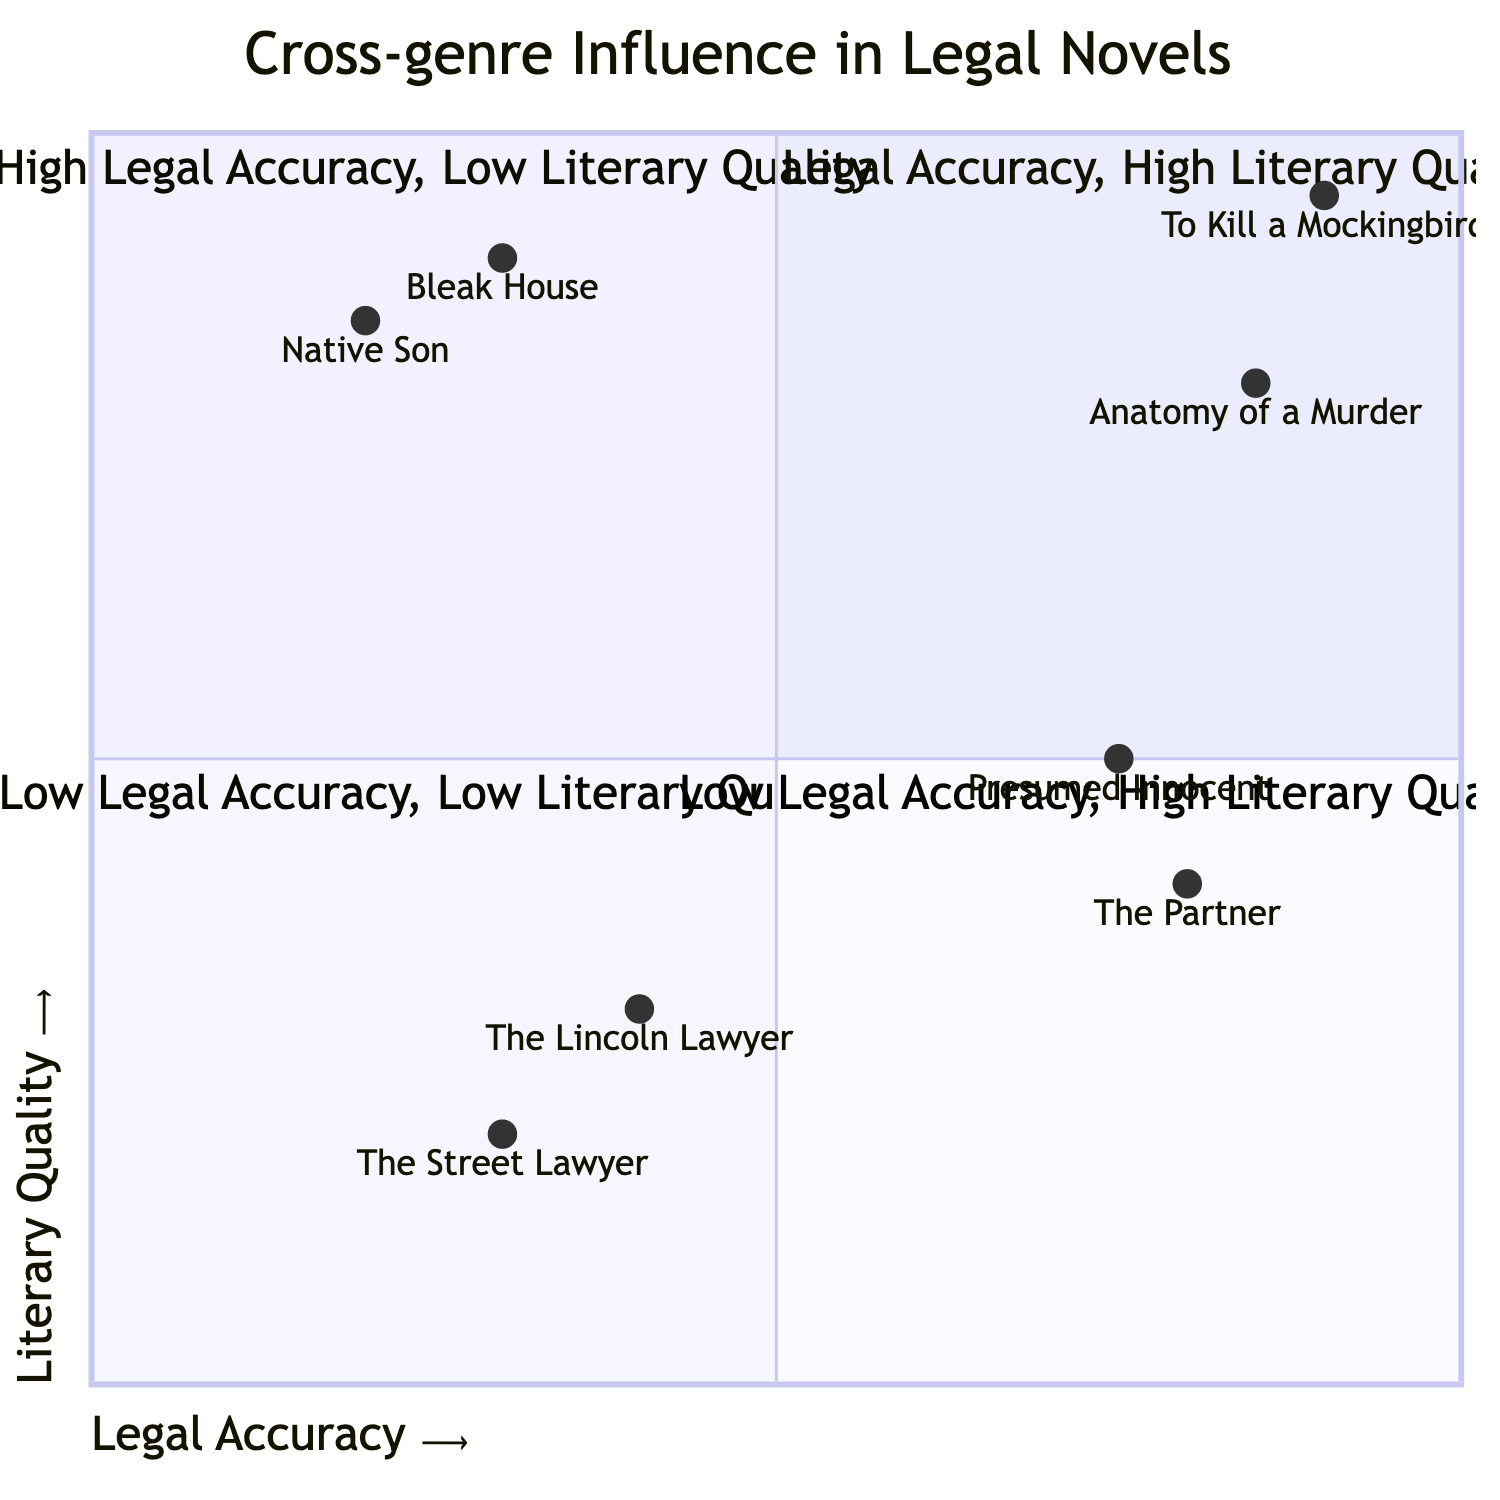What is the title of the novel in the High Legal Accuracy, High Literary Quality quadrant? The High Legal Accuracy, High Literary Quality quadrant includes notable examples; from the provided data, "To Kill a Mockingbird" by Harper Lee is listed as one of the novels in this quadrant.
Answer: To Kill a Mockingbird How many novels are in the Low Legal Accuracy, Low Literary Quality quadrant? The Low Legal Accuracy, Low Literary Quality quadrant contains two examples: "The Lincoln Lawyer" and "The Street Lawyer". Therefore, the total number of novels in this quadrant is two.
Answer: 2 Which novel has the highest literary quality among the ones in the diagram? By examining the values in the quadrants, "To Kill a Mockingbird" has the highest literary quality at 0.95, making it the novel with the highest literary quality overall.
Answer: To Kill a Mockingbird What is the legal accuracy value of "Native Son"? The data indicates that "Native Son" has a legal accuracy value of 0.2, which identifies its placement in the diagram concerning legal accuracy.
Answer: 0.2 Which quadrant features novels with strong legal procedures but lower literary depth? The quadrant that features novels with strong legal procedures but lower literary depth is the High Legal Accuracy, Low Literary Quality quadrant, where novels like "The Partner" and "Presumed Innocent" appear.
Answer: High Legal Accuracy, Low Literary Quality What is the literary quality score of "The Partner"? According to the data, "The Partner" has a literary quality score of 0.4, representing its level of literary depth in the context of the diagram.
Answer: 0.4 Which two novels share the same legal accuracy score of 0.3? "The Lincoln Lawyer" and "The Street Lawyer" both possess a legal accuracy score of 0.3, making them equal in this aspect within the diagram.
Answer: The Lincoln Lawyer and The Street Lawyer In which quadrant does "Bleak House" belong? "Bleak House" is categorized in the Low Legal Accuracy, High Literary Quality quadrant, reflecting its emphasis on literary quality over strict legal accuracy.
Answer: Low Legal Accuracy, High Literary Quality 